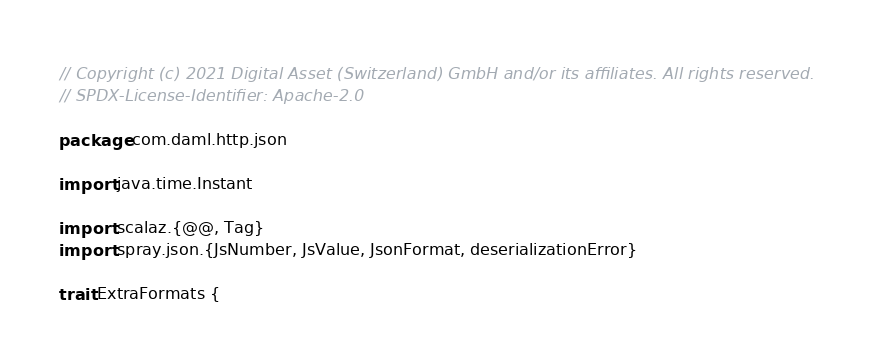<code> <loc_0><loc_0><loc_500><loc_500><_Scala_>// Copyright (c) 2021 Digital Asset (Switzerland) GmbH and/or its affiliates. All rights reserved.
// SPDX-License-Identifier: Apache-2.0

package com.daml.http.json

import java.time.Instant

import scalaz.{@@, Tag}
import spray.json.{JsNumber, JsValue, JsonFormat, deserializationError}

trait ExtraFormats {
</code> 